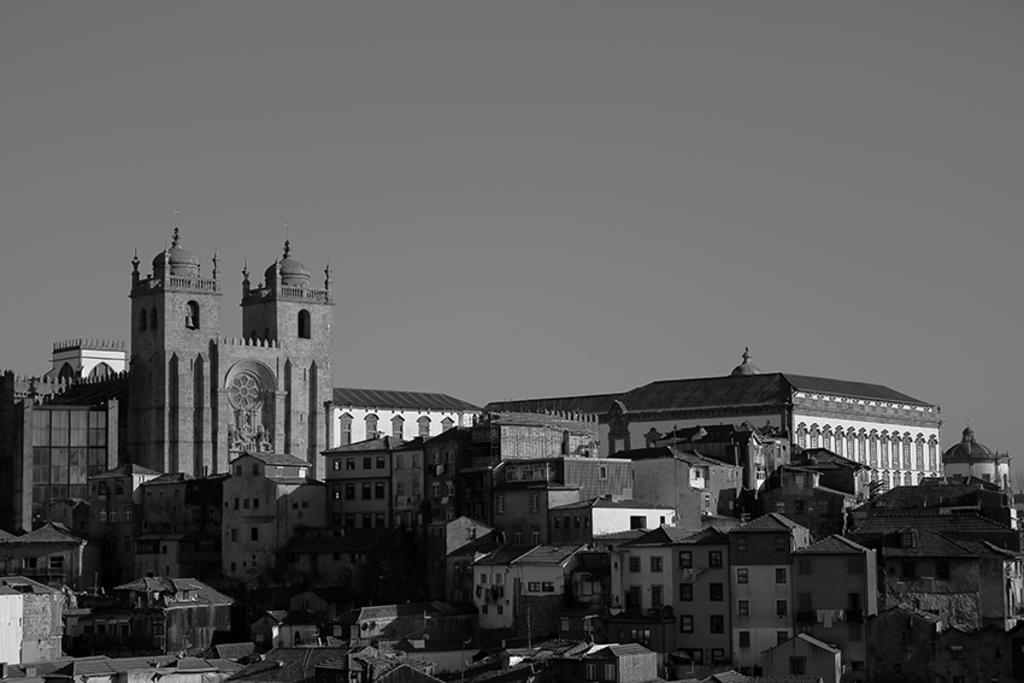What type of structures can be seen in the image? There are many buildings, monuments, a shed, and a church in the image. Can you describe the sky in the image? The sky is visible at the top of the image. Are there any specific features on the roof of a building in the image? Yes, there are poles on the roof of a building at the bottom of the image. What type of blade can be seen cutting through the steam in the image? There is no blade or steam present in the image. How many matches are visible in the image? There are no matches present in the image. 